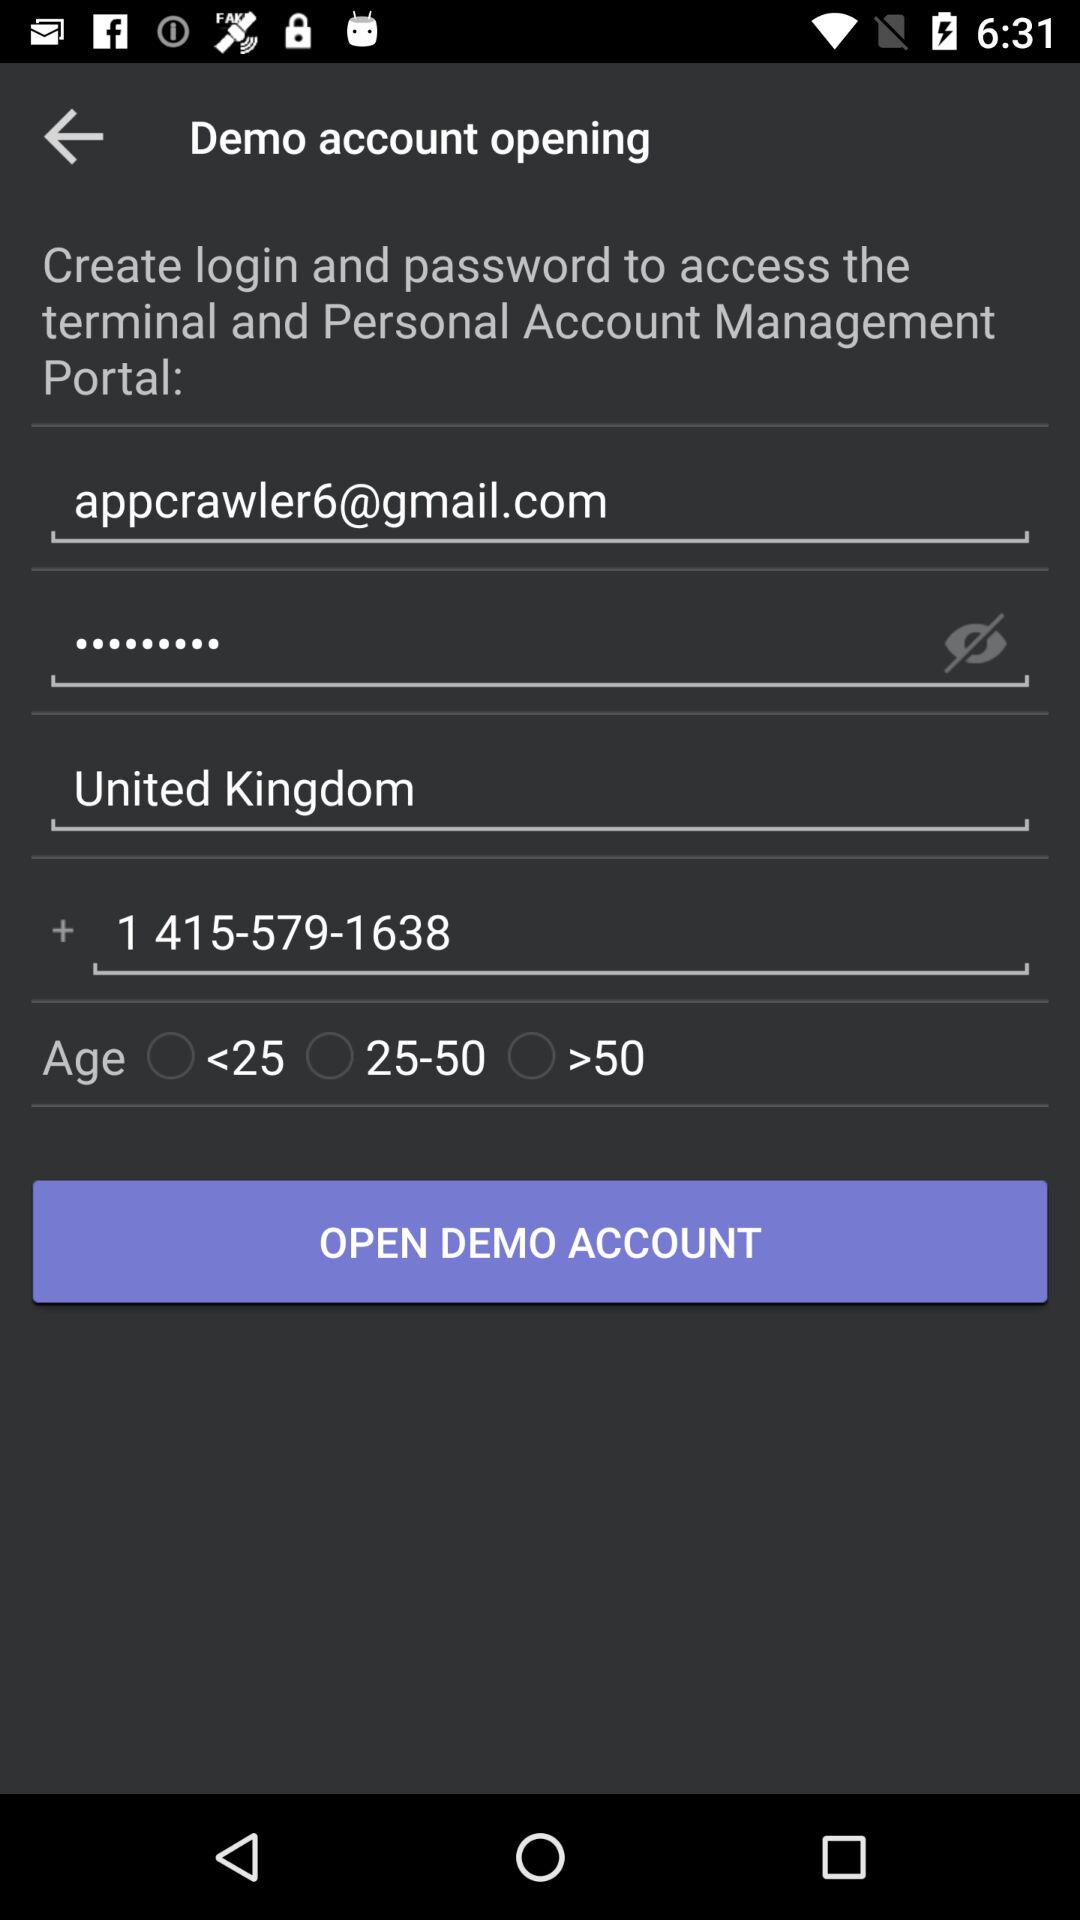What are the options available for age? The available options are "<25", "25-50" and ">50". 